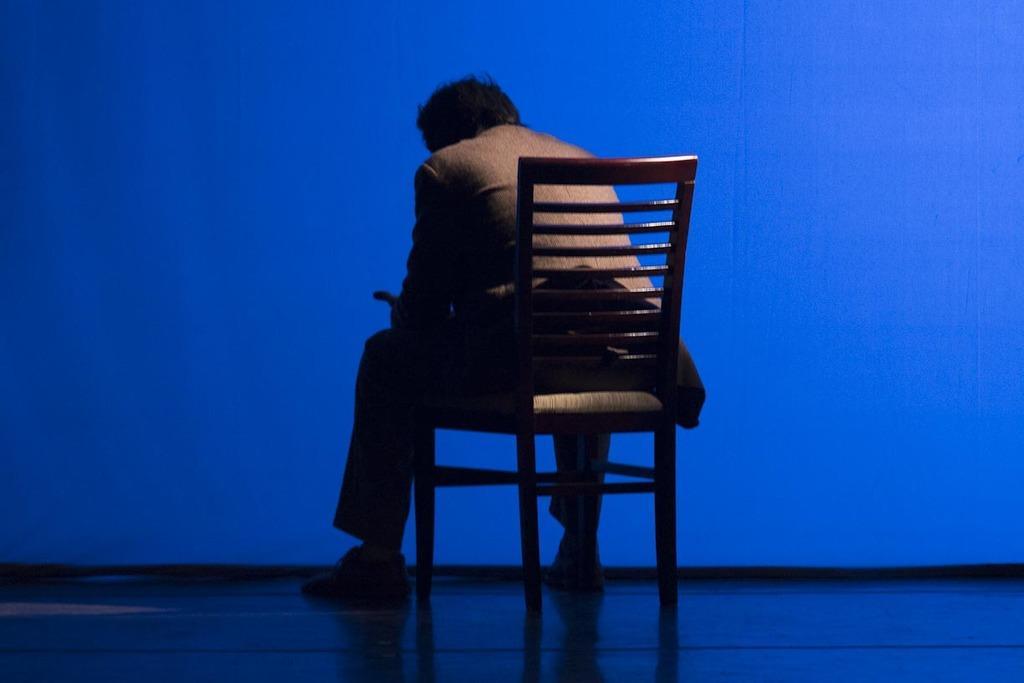In one or two sentences, can you explain what this image depicts? Background portion of the picture is in blue color. In this picture we can see a man sitting on a chair. At the bottom portion of the picture we can see the platform. 